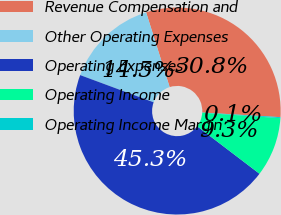Convert chart. <chart><loc_0><loc_0><loc_500><loc_500><pie_chart><fcel>Revenue Compensation and<fcel>Other Operating Expenses<fcel>Operating Expenses<fcel>Operating Income<fcel>Operating Income Margin<nl><fcel>30.8%<fcel>14.5%<fcel>45.29%<fcel>9.27%<fcel>0.15%<nl></chart> 